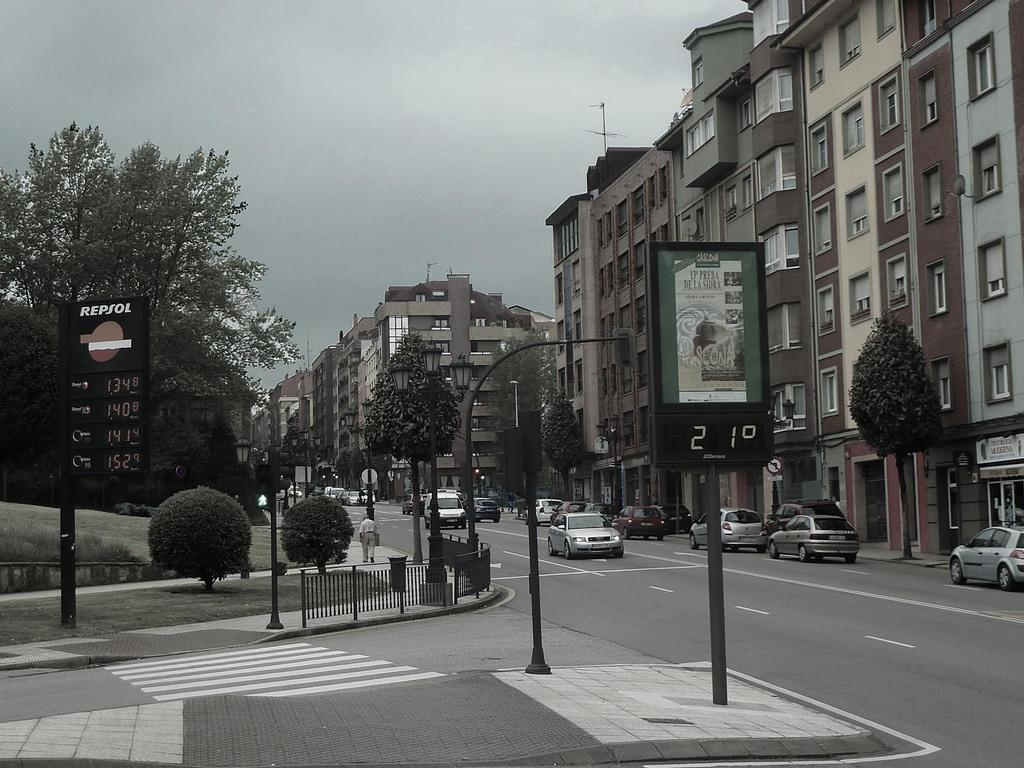<image>
Render a clear and concise summary of the photo. A view of a street and a sign showing the current temperature of 21 degrees. 